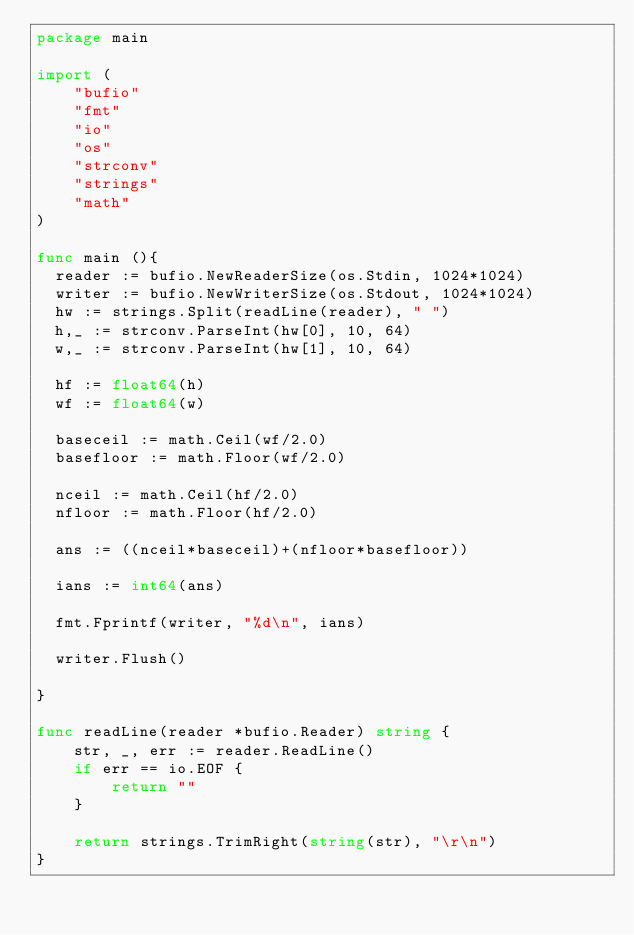<code> <loc_0><loc_0><loc_500><loc_500><_Go_>package main

import (
    "bufio"
    "fmt"
    "io"
    "os"
    "strconv"
    "strings"
    "math"
)

func main (){
	reader := bufio.NewReaderSize(os.Stdin, 1024*1024)
	writer := bufio.NewWriterSize(os.Stdout, 1024*1024)
	hw := strings.Split(readLine(reader), " ")
	h,_ := strconv.ParseInt(hw[0], 10, 64)
	w,_ := strconv.ParseInt(hw[1], 10, 64)
	
	hf := float64(h)
	wf := float64(w)
	
	baseceil := math.Ceil(wf/2.0)
	basefloor := math.Floor(wf/2.0)
	
	nceil := math.Ceil(hf/2.0)
	nfloor := math.Floor(hf/2.0)
	
	ans := ((nceil*baseceil)+(nfloor*basefloor))
	
	ians := int64(ans)
	
	fmt.Fprintf(writer, "%d\n", ians)
	
	writer.Flush()
	
}

func readLine(reader *bufio.Reader) string {
    str, _, err := reader.ReadLine()
    if err == io.EOF {
        return ""
    }

    return strings.TrimRight(string(str), "\r\n")
}</code> 